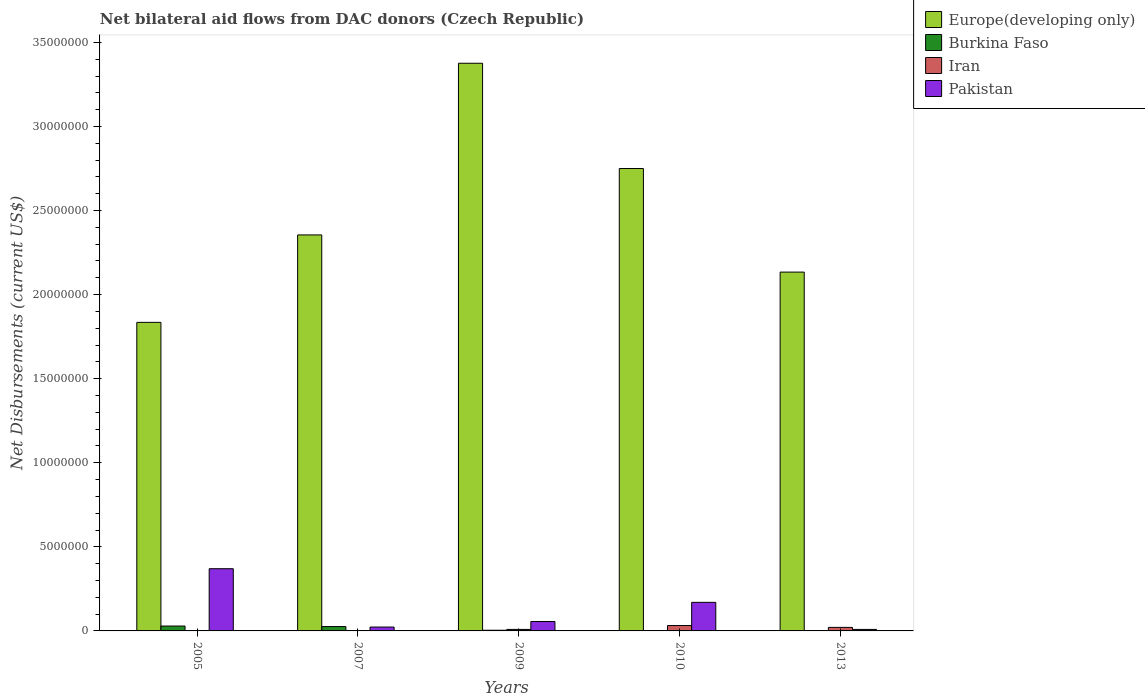How many different coloured bars are there?
Ensure brevity in your answer.  4. Are the number of bars per tick equal to the number of legend labels?
Keep it short and to the point. Yes. Are the number of bars on each tick of the X-axis equal?
Provide a succinct answer. Yes. How many bars are there on the 2nd tick from the left?
Give a very brief answer. 4. How many bars are there on the 5th tick from the right?
Your response must be concise. 4. What is the net bilateral aid flows in Europe(developing only) in 2009?
Provide a succinct answer. 3.38e+07. Across all years, what is the maximum net bilateral aid flows in Burkina Faso?
Give a very brief answer. 2.90e+05. In which year was the net bilateral aid flows in Europe(developing only) maximum?
Offer a terse response. 2009. What is the total net bilateral aid flows in Burkina Faso in the graph?
Provide a short and direct response. 6.20e+05. What is the difference between the net bilateral aid flows in Iran in 2007 and that in 2009?
Ensure brevity in your answer.  -7.00e+04. What is the difference between the net bilateral aid flows in Iran in 2007 and the net bilateral aid flows in Europe(developing only) in 2009?
Keep it short and to the point. -3.37e+07. What is the average net bilateral aid flows in Europe(developing only) per year?
Make the answer very short. 2.49e+07. In the year 2005, what is the difference between the net bilateral aid flows in Pakistan and net bilateral aid flows in Burkina Faso?
Offer a terse response. 3.41e+06. In how many years, is the net bilateral aid flows in Europe(developing only) greater than 33000000 US$?
Provide a short and direct response. 1. What is the ratio of the net bilateral aid flows in Burkina Faso in 2009 to that in 2013?
Your answer should be very brief. 4. Is the net bilateral aid flows in Burkina Faso in 2007 less than that in 2009?
Provide a succinct answer. No. Is the difference between the net bilateral aid flows in Pakistan in 2005 and 2010 greater than the difference between the net bilateral aid flows in Burkina Faso in 2005 and 2010?
Your answer should be compact. Yes. What is the difference between the highest and the lowest net bilateral aid flows in Burkina Faso?
Your answer should be compact. 2.80e+05. In how many years, is the net bilateral aid flows in Burkina Faso greater than the average net bilateral aid flows in Burkina Faso taken over all years?
Offer a very short reply. 2. Is it the case that in every year, the sum of the net bilateral aid flows in Europe(developing only) and net bilateral aid flows in Burkina Faso is greater than the sum of net bilateral aid flows in Pakistan and net bilateral aid flows in Iran?
Your answer should be compact. Yes. What does the 2nd bar from the left in 2010 represents?
Your answer should be compact. Burkina Faso. What does the 4th bar from the right in 2010 represents?
Offer a very short reply. Europe(developing only). What is the difference between two consecutive major ticks on the Y-axis?
Give a very brief answer. 5.00e+06. Does the graph contain any zero values?
Provide a short and direct response. No. Does the graph contain grids?
Your answer should be compact. No. Where does the legend appear in the graph?
Provide a short and direct response. Top right. How many legend labels are there?
Ensure brevity in your answer.  4. How are the legend labels stacked?
Make the answer very short. Vertical. What is the title of the graph?
Give a very brief answer. Net bilateral aid flows from DAC donors (Czech Republic). Does "Sao Tome and Principe" appear as one of the legend labels in the graph?
Give a very brief answer. No. What is the label or title of the X-axis?
Your answer should be compact. Years. What is the label or title of the Y-axis?
Your answer should be very brief. Net Disbursements (current US$). What is the Net Disbursements (current US$) of Europe(developing only) in 2005?
Offer a terse response. 1.84e+07. What is the Net Disbursements (current US$) in Pakistan in 2005?
Offer a terse response. 3.70e+06. What is the Net Disbursements (current US$) of Europe(developing only) in 2007?
Provide a succinct answer. 2.36e+07. What is the Net Disbursements (current US$) in Iran in 2007?
Provide a succinct answer. 2.00e+04. What is the Net Disbursements (current US$) in Pakistan in 2007?
Offer a very short reply. 2.30e+05. What is the Net Disbursements (current US$) in Europe(developing only) in 2009?
Your answer should be very brief. 3.38e+07. What is the Net Disbursements (current US$) of Iran in 2009?
Ensure brevity in your answer.  9.00e+04. What is the Net Disbursements (current US$) in Pakistan in 2009?
Offer a terse response. 5.60e+05. What is the Net Disbursements (current US$) in Europe(developing only) in 2010?
Your response must be concise. 2.75e+07. What is the Net Disbursements (current US$) of Burkina Faso in 2010?
Offer a very short reply. 2.00e+04. What is the Net Disbursements (current US$) of Pakistan in 2010?
Your response must be concise. 1.70e+06. What is the Net Disbursements (current US$) of Europe(developing only) in 2013?
Provide a short and direct response. 2.13e+07. What is the Net Disbursements (current US$) in Pakistan in 2013?
Your answer should be compact. 9.00e+04. Across all years, what is the maximum Net Disbursements (current US$) in Europe(developing only)?
Give a very brief answer. 3.38e+07. Across all years, what is the maximum Net Disbursements (current US$) of Pakistan?
Ensure brevity in your answer.  3.70e+06. Across all years, what is the minimum Net Disbursements (current US$) of Europe(developing only)?
Your answer should be very brief. 1.84e+07. Across all years, what is the minimum Net Disbursements (current US$) in Burkina Faso?
Provide a succinct answer. 10000. What is the total Net Disbursements (current US$) of Europe(developing only) in the graph?
Give a very brief answer. 1.24e+08. What is the total Net Disbursements (current US$) in Burkina Faso in the graph?
Provide a succinct answer. 6.20e+05. What is the total Net Disbursements (current US$) in Pakistan in the graph?
Ensure brevity in your answer.  6.28e+06. What is the difference between the Net Disbursements (current US$) in Europe(developing only) in 2005 and that in 2007?
Keep it short and to the point. -5.20e+06. What is the difference between the Net Disbursements (current US$) in Pakistan in 2005 and that in 2007?
Your answer should be very brief. 3.47e+06. What is the difference between the Net Disbursements (current US$) in Europe(developing only) in 2005 and that in 2009?
Your response must be concise. -1.54e+07. What is the difference between the Net Disbursements (current US$) in Burkina Faso in 2005 and that in 2009?
Offer a terse response. 2.50e+05. What is the difference between the Net Disbursements (current US$) in Iran in 2005 and that in 2009?
Your answer should be compact. -7.00e+04. What is the difference between the Net Disbursements (current US$) in Pakistan in 2005 and that in 2009?
Your answer should be very brief. 3.14e+06. What is the difference between the Net Disbursements (current US$) of Europe(developing only) in 2005 and that in 2010?
Your response must be concise. -9.15e+06. What is the difference between the Net Disbursements (current US$) of Burkina Faso in 2005 and that in 2010?
Keep it short and to the point. 2.70e+05. What is the difference between the Net Disbursements (current US$) in Europe(developing only) in 2005 and that in 2013?
Provide a succinct answer. -2.99e+06. What is the difference between the Net Disbursements (current US$) of Burkina Faso in 2005 and that in 2013?
Give a very brief answer. 2.80e+05. What is the difference between the Net Disbursements (current US$) of Iran in 2005 and that in 2013?
Offer a terse response. -1.90e+05. What is the difference between the Net Disbursements (current US$) of Pakistan in 2005 and that in 2013?
Ensure brevity in your answer.  3.61e+06. What is the difference between the Net Disbursements (current US$) in Europe(developing only) in 2007 and that in 2009?
Keep it short and to the point. -1.02e+07. What is the difference between the Net Disbursements (current US$) in Burkina Faso in 2007 and that in 2009?
Give a very brief answer. 2.20e+05. What is the difference between the Net Disbursements (current US$) in Iran in 2007 and that in 2009?
Give a very brief answer. -7.00e+04. What is the difference between the Net Disbursements (current US$) in Pakistan in 2007 and that in 2009?
Keep it short and to the point. -3.30e+05. What is the difference between the Net Disbursements (current US$) in Europe(developing only) in 2007 and that in 2010?
Your answer should be very brief. -3.95e+06. What is the difference between the Net Disbursements (current US$) in Pakistan in 2007 and that in 2010?
Provide a short and direct response. -1.47e+06. What is the difference between the Net Disbursements (current US$) of Europe(developing only) in 2007 and that in 2013?
Make the answer very short. 2.21e+06. What is the difference between the Net Disbursements (current US$) of Iran in 2007 and that in 2013?
Provide a succinct answer. -1.90e+05. What is the difference between the Net Disbursements (current US$) in Pakistan in 2007 and that in 2013?
Make the answer very short. 1.40e+05. What is the difference between the Net Disbursements (current US$) of Europe(developing only) in 2009 and that in 2010?
Make the answer very short. 6.26e+06. What is the difference between the Net Disbursements (current US$) in Burkina Faso in 2009 and that in 2010?
Your answer should be very brief. 2.00e+04. What is the difference between the Net Disbursements (current US$) of Pakistan in 2009 and that in 2010?
Offer a terse response. -1.14e+06. What is the difference between the Net Disbursements (current US$) in Europe(developing only) in 2009 and that in 2013?
Provide a short and direct response. 1.24e+07. What is the difference between the Net Disbursements (current US$) of Burkina Faso in 2009 and that in 2013?
Your response must be concise. 3.00e+04. What is the difference between the Net Disbursements (current US$) in Europe(developing only) in 2010 and that in 2013?
Give a very brief answer. 6.16e+06. What is the difference between the Net Disbursements (current US$) in Pakistan in 2010 and that in 2013?
Your answer should be compact. 1.61e+06. What is the difference between the Net Disbursements (current US$) in Europe(developing only) in 2005 and the Net Disbursements (current US$) in Burkina Faso in 2007?
Ensure brevity in your answer.  1.81e+07. What is the difference between the Net Disbursements (current US$) of Europe(developing only) in 2005 and the Net Disbursements (current US$) of Iran in 2007?
Offer a terse response. 1.83e+07. What is the difference between the Net Disbursements (current US$) in Europe(developing only) in 2005 and the Net Disbursements (current US$) in Pakistan in 2007?
Your response must be concise. 1.81e+07. What is the difference between the Net Disbursements (current US$) of Burkina Faso in 2005 and the Net Disbursements (current US$) of Pakistan in 2007?
Your response must be concise. 6.00e+04. What is the difference between the Net Disbursements (current US$) of Europe(developing only) in 2005 and the Net Disbursements (current US$) of Burkina Faso in 2009?
Provide a short and direct response. 1.83e+07. What is the difference between the Net Disbursements (current US$) of Europe(developing only) in 2005 and the Net Disbursements (current US$) of Iran in 2009?
Offer a terse response. 1.83e+07. What is the difference between the Net Disbursements (current US$) of Europe(developing only) in 2005 and the Net Disbursements (current US$) of Pakistan in 2009?
Give a very brief answer. 1.78e+07. What is the difference between the Net Disbursements (current US$) of Burkina Faso in 2005 and the Net Disbursements (current US$) of Iran in 2009?
Ensure brevity in your answer.  2.00e+05. What is the difference between the Net Disbursements (current US$) in Burkina Faso in 2005 and the Net Disbursements (current US$) in Pakistan in 2009?
Your answer should be compact. -2.70e+05. What is the difference between the Net Disbursements (current US$) in Iran in 2005 and the Net Disbursements (current US$) in Pakistan in 2009?
Provide a short and direct response. -5.40e+05. What is the difference between the Net Disbursements (current US$) in Europe(developing only) in 2005 and the Net Disbursements (current US$) in Burkina Faso in 2010?
Keep it short and to the point. 1.83e+07. What is the difference between the Net Disbursements (current US$) of Europe(developing only) in 2005 and the Net Disbursements (current US$) of Iran in 2010?
Your response must be concise. 1.80e+07. What is the difference between the Net Disbursements (current US$) in Europe(developing only) in 2005 and the Net Disbursements (current US$) in Pakistan in 2010?
Your response must be concise. 1.66e+07. What is the difference between the Net Disbursements (current US$) in Burkina Faso in 2005 and the Net Disbursements (current US$) in Iran in 2010?
Your answer should be very brief. -3.00e+04. What is the difference between the Net Disbursements (current US$) of Burkina Faso in 2005 and the Net Disbursements (current US$) of Pakistan in 2010?
Your answer should be very brief. -1.41e+06. What is the difference between the Net Disbursements (current US$) of Iran in 2005 and the Net Disbursements (current US$) of Pakistan in 2010?
Offer a very short reply. -1.68e+06. What is the difference between the Net Disbursements (current US$) in Europe(developing only) in 2005 and the Net Disbursements (current US$) in Burkina Faso in 2013?
Offer a very short reply. 1.83e+07. What is the difference between the Net Disbursements (current US$) in Europe(developing only) in 2005 and the Net Disbursements (current US$) in Iran in 2013?
Ensure brevity in your answer.  1.81e+07. What is the difference between the Net Disbursements (current US$) in Europe(developing only) in 2005 and the Net Disbursements (current US$) in Pakistan in 2013?
Ensure brevity in your answer.  1.83e+07. What is the difference between the Net Disbursements (current US$) of Burkina Faso in 2005 and the Net Disbursements (current US$) of Pakistan in 2013?
Your answer should be compact. 2.00e+05. What is the difference between the Net Disbursements (current US$) of Iran in 2005 and the Net Disbursements (current US$) of Pakistan in 2013?
Your response must be concise. -7.00e+04. What is the difference between the Net Disbursements (current US$) in Europe(developing only) in 2007 and the Net Disbursements (current US$) in Burkina Faso in 2009?
Provide a short and direct response. 2.35e+07. What is the difference between the Net Disbursements (current US$) of Europe(developing only) in 2007 and the Net Disbursements (current US$) of Iran in 2009?
Your answer should be compact. 2.35e+07. What is the difference between the Net Disbursements (current US$) of Europe(developing only) in 2007 and the Net Disbursements (current US$) of Pakistan in 2009?
Keep it short and to the point. 2.30e+07. What is the difference between the Net Disbursements (current US$) in Iran in 2007 and the Net Disbursements (current US$) in Pakistan in 2009?
Provide a short and direct response. -5.40e+05. What is the difference between the Net Disbursements (current US$) of Europe(developing only) in 2007 and the Net Disbursements (current US$) of Burkina Faso in 2010?
Your response must be concise. 2.35e+07. What is the difference between the Net Disbursements (current US$) of Europe(developing only) in 2007 and the Net Disbursements (current US$) of Iran in 2010?
Offer a very short reply. 2.32e+07. What is the difference between the Net Disbursements (current US$) in Europe(developing only) in 2007 and the Net Disbursements (current US$) in Pakistan in 2010?
Ensure brevity in your answer.  2.18e+07. What is the difference between the Net Disbursements (current US$) of Burkina Faso in 2007 and the Net Disbursements (current US$) of Iran in 2010?
Provide a short and direct response. -6.00e+04. What is the difference between the Net Disbursements (current US$) in Burkina Faso in 2007 and the Net Disbursements (current US$) in Pakistan in 2010?
Provide a short and direct response. -1.44e+06. What is the difference between the Net Disbursements (current US$) in Iran in 2007 and the Net Disbursements (current US$) in Pakistan in 2010?
Your response must be concise. -1.68e+06. What is the difference between the Net Disbursements (current US$) of Europe(developing only) in 2007 and the Net Disbursements (current US$) of Burkina Faso in 2013?
Make the answer very short. 2.35e+07. What is the difference between the Net Disbursements (current US$) of Europe(developing only) in 2007 and the Net Disbursements (current US$) of Iran in 2013?
Provide a short and direct response. 2.33e+07. What is the difference between the Net Disbursements (current US$) of Europe(developing only) in 2007 and the Net Disbursements (current US$) of Pakistan in 2013?
Offer a very short reply. 2.35e+07. What is the difference between the Net Disbursements (current US$) of Burkina Faso in 2007 and the Net Disbursements (current US$) of Iran in 2013?
Your answer should be compact. 5.00e+04. What is the difference between the Net Disbursements (current US$) in Burkina Faso in 2007 and the Net Disbursements (current US$) in Pakistan in 2013?
Your answer should be compact. 1.70e+05. What is the difference between the Net Disbursements (current US$) in Europe(developing only) in 2009 and the Net Disbursements (current US$) in Burkina Faso in 2010?
Provide a succinct answer. 3.37e+07. What is the difference between the Net Disbursements (current US$) in Europe(developing only) in 2009 and the Net Disbursements (current US$) in Iran in 2010?
Give a very brief answer. 3.34e+07. What is the difference between the Net Disbursements (current US$) of Europe(developing only) in 2009 and the Net Disbursements (current US$) of Pakistan in 2010?
Your response must be concise. 3.21e+07. What is the difference between the Net Disbursements (current US$) of Burkina Faso in 2009 and the Net Disbursements (current US$) of Iran in 2010?
Your answer should be compact. -2.80e+05. What is the difference between the Net Disbursements (current US$) of Burkina Faso in 2009 and the Net Disbursements (current US$) of Pakistan in 2010?
Give a very brief answer. -1.66e+06. What is the difference between the Net Disbursements (current US$) in Iran in 2009 and the Net Disbursements (current US$) in Pakistan in 2010?
Make the answer very short. -1.61e+06. What is the difference between the Net Disbursements (current US$) in Europe(developing only) in 2009 and the Net Disbursements (current US$) in Burkina Faso in 2013?
Provide a succinct answer. 3.38e+07. What is the difference between the Net Disbursements (current US$) of Europe(developing only) in 2009 and the Net Disbursements (current US$) of Iran in 2013?
Make the answer very short. 3.36e+07. What is the difference between the Net Disbursements (current US$) of Europe(developing only) in 2009 and the Net Disbursements (current US$) of Pakistan in 2013?
Give a very brief answer. 3.37e+07. What is the difference between the Net Disbursements (current US$) of Burkina Faso in 2009 and the Net Disbursements (current US$) of Iran in 2013?
Provide a succinct answer. -1.70e+05. What is the difference between the Net Disbursements (current US$) in Europe(developing only) in 2010 and the Net Disbursements (current US$) in Burkina Faso in 2013?
Offer a terse response. 2.75e+07. What is the difference between the Net Disbursements (current US$) in Europe(developing only) in 2010 and the Net Disbursements (current US$) in Iran in 2013?
Provide a succinct answer. 2.73e+07. What is the difference between the Net Disbursements (current US$) of Europe(developing only) in 2010 and the Net Disbursements (current US$) of Pakistan in 2013?
Offer a very short reply. 2.74e+07. What is the difference between the Net Disbursements (current US$) of Burkina Faso in 2010 and the Net Disbursements (current US$) of Iran in 2013?
Make the answer very short. -1.90e+05. What is the difference between the Net Disbursements (current US$) in Iran in 2010 and the Net Disbursements (current US$) in Pakistan in 2013?
Offer a terse response. 2.30e+05. What is the average Net Disbursements (current US$) of Europe(developing only) per year?
Your answer should be compact. 2.49e+07. What is the average Net Disbursements (current US$) in Burkina Faso per year?
Give a very brief answer. 1.24e+05. What is the average Net Disbursements (current US$) of Iran per year?
Provide a succinct answer. 1.32e+05. What is the average Net Disbursements (current US$) of Pakistan per year?
Offer a very short reply. 1.26e+06. In the year 2005, what is the difference between the Net Disbursements (current US$) in Europe(developing only) and Net Disbursements (current US$) in Burkina Faso?
Your answer should be compact. 1.81e+07. In the year 2005, what is the difference between the Net Disbursements (current US$) in Europe(developing only) and Net Disbursements (current US$) in Iran?
Provide a short and direct response. 1.83e+07. In the year 2005, what is the difference between the Net Disbursements (current US$) in Europe(developing only) and Net Disbursements (current US$) in Pakistan?
Ensure brevity in your answer.  1.46e+07. In the year 2005, what is the difference between the Net Disbursements (current US$) in Burkina Faso and Net Disbursements (current US$) in Pakistan?
Your response must be concise. -3.41e+06. In the year 2005, what is the difference between the Net Disbursements (current US$) of Iran and Net Disbursements (current US$) of Pakistan?
Your answer should be very brief. -3.68e+06. In the year 2007, what is the difference between the Net Disbursements (current US$) in Europe(developing only) and Net Disbursements (current US$) in Burkina Faso?
Provide a succinct answer. 2.33e+07. In the year 2007, what is the difference between the Net Disbursements (current US$) in Europe(developing only) and Net Disbursements (current US$) in Iran?
Your answer should be very brief. 2.35e+07. In the year 2007, what is the difference between the Net Disbursements (current US$) of Europe(developing only) and Net Disbursements (current US$) of Pakistan?
Provide a short and direct response. 2.33e+07. In the year 2007, what is the difference between the Net Disbursements (current US$) in Burkina Faso and Net Disbursements (current US$) in Iran?
Provide a short and direct response. 2.40e+05. In the year 2009, what is the difference between the Net Disbursements (current US$) in Europe(developing only) and Net Disbursements (current US$) in Burkina Faso?
Offer a terse response. 3.37e+07. In the year 2009, what is the difference between the Net Disbursements (current US$) in Europe(developing only) and Net Disbursements (current US$) in Iran?
Give a very brief answer. 3.37e+07. In the year 2009, what is the difference between the Net Disbursements (current US$) in Europe(developing only) and Net Disbursements (current US$) in Pakistan?
Offer a very short reply. 3.32e+07. In the year 2009, what is the difference between the Net Disbursements (current US$) in Burkina Faso and Net Disbursements (current US$) in Iran?
Keep it short and to the point. -5.00e+04. In the year 2009, what is the difference between the Net Disbursements (current US$) of Burkina Faso and Net Disbursements (current US$) of Pakistan?
Ensure brevity in your answer.  -5.20e+05. In the year 2009, what is the difference between the Net Disbursements (current US$) of Iran and Net Disbursements (current US$) of Pakistan?
Your response must be concise. -4.70e+05. In the year 2010, what is the difference between the Net Disbursements (current US$) in Europe(developing only) and Net Disbursements (current US$) in Burkina Faso?
Provide a short and direct response. 2.75e+07. In the year 2010, what is the difference between the Net Disbursements (current US$) of Europe(developing only) and Net Disbursements (current US$) of Iran?
Your response must be concise. 2.72e+07. In the year 2010, what is the difference between the Net Disbursements (current US$) in Europe(developing only) and Net Disbursements (current US$) in Pakistan?
Offer a very short reply. 2.58e+07. In the year 2010, what is the difference between the Net Disbursements (current US$) in Burkina Faso and Net Disbursements (current US$) in Pakistan?
Provide a succinct answer. -1.68e+06. In the year 2010, what is the difference between the Net Disbursements (current US$) in Iran and Net Disbursements (current US$) in Pakistan?
Offer a terse response. -1.38e+06. In the year 2013, what is the difference between the Net Disbursements (current US$) of Europe(developing only) and Net Disbursements (current US$) of Burkina Faso?
Provide a succinct answer. 2.13e+07. In the year 2013, what is the difference between the Net Disbursements (current US$) in Europe(developing only) and Net Disbursements (current US$) in Iran?
Offer a terse response. 2.11e+07. In the year 2013, what is the difference between the Net Disbursements (current US$) in Europe(developing only) and Net Disbursements (current US$) in Pakistan?
Offer a terse response. 2.12e+07. In the year 2013, what is the difference between the Net Disbursements (current US$) of Burkina Faso and Net Disbursements (current US$) of Iran?
Offer a terse response. -2.00e+05. In the year 2013, what is the difference between the Net Disbursements (current US$) in Burkina Faso and Net Disbursements (current US$) in Pakistan?
Your answer should be compact. -8.00e+04. What is the ratio of the Net Disbursements (current US$) in Europe(developing only) in 2005 to that in 2007?
Make the answer very short. 0.78. What is the ratio of the Net Disbursements (current US$) of Burkina Faso in 2005 to that in 2007?
Provide a short and direct response. 1.12. What is the ratio of the Net Disbursements (current US$) in Pakistan in 2005 to that in 2007?
Provide a succinct answer. 16.09. What is the ratio of the Net Disbursements (current US$) of Europe(developing only) in 2005 to that in 2009?
Provide a succinct answer. 0.54. What is the ratio of the Net Disbursements (current US$) of Burkina Faso in 2005 to that in 2009?
Ensure brevity in your answer.  7.25. What is the ratio of the Net Disbursements (current US$) in Iran in 2005 to that in 2009?
Keep it short and to the point. 0.22. What is the ratio of the Net Disbursements (current US$) of Pakistan in 2005 to that in 2009?
Offer a terse response. 6.61. What is the ratio of the Net Disbursements (current US$) of Europe(developing only) in 2005 to that in 2010?
Your answer should be compact. 0.67. What is the ratio of the Net Disbursements (current US$) of Iran in 2005 to that in 2010?
Your answer should be very brief. 0.06. What is the ratio of the Net Disbursements (current US$) of Pakistan in 2005 to that in 2010?
Offer a terse response. 2.18. What is the ratio of the Net Disbursements (current US$) of Europe(developing only) in 2005 to that in 2013?
Provide a short and direct response. 0.86. What is the ratio of the Net Disbursements (current US$) of Burkina Faso in 2005 to that in 2013?
Make the answer very short. 29. What is the ratio of the Net Disbursements (current US$) of Iran in 2005 to that in 2013?
Your answer should be very brief. 0.1. What is the ratio of the Net Disbursements (current US$) of Pakistan in 2005 to that in 2013?
Ensure brevity in your answer.  41.11. What is the ratio of the Net Disbursements (current US$) in Europe(developing only) in 2007 to that in 2009?
Provide a short and direct response. 0.7. What is the ratio of the Net Disbursements (current US$) in Iran in 2007 to that in 2009?
Your response must be concise. 0.22. What is the ratio of the Net Disbursements (current US$) in Pakistan in 2007 to that in 2009?
Give a very brief answer. 0.41. What is the ratio of the Net Disbursements (current US$) of Europe(developing only) in 2007 to that in 2010?
Your response must be concise. 0.86. What is the ratio of the Net Disbursements (current US$) in Iran in 2007 to that in 2010?
Offer a terse response. 0.06. What is the ratio of the Net Disbursements (current US$) in Pakistan in 2007 to that in 2010?
Provide a succinct answer. 0.14. What is the ratio of the Net Disbursements (current US$) of Europe(developing only) in 2007 to that in 2013?
Provide a succinct answer. 1.1. What is the ratio of the Net Disbursements (current US$) of Iran in 2007 to that in 2013?
Your answer should be very brief. 0.1. What is the ratio of the Net Disbursements (current US$) of Pakistan in 2007 to that in 2013?
Your answer should be compact. 2.56. What is the ratio of the Net Disbursements (current US$) in Europe(developing only) in 2009 to that in 2010?
Keep it short and to the point. 1.23. What is the ratio of the Net Disbursements (current US$) in Burkina Faso in 2009 to that in 2010?
Make the answer very short. 2. What is the ratio of the Net Disbursements (current US$) of Iran in 2009 to that in 2010?
Give a very brief answer. 0.28. What is the ratio of the Net Disbursements (current US$) in Pakistan in 2009 to that in 2010?
Offer a terse response. 0.33. What is the ratio of the Net Disbursements (current US$) of Europe(developing only) in 2009 to that in 2013?
Make the answer very short. 1.58. What is the ratio of the Net Disbursements (current US$) of Burkina Faso in 2009 to that in 2013?
Give a very brief answer. 4. What is the ratio of the Net Disbursements (current US$) in Iran in 2009 to that in 2013?
Your answer should be very brief. 0.43. What is the ratio of the Net Disbursements (current US$) of Pakistan in 2009 to that in 2013?
Ensure brevity in your answer.  6.22. What is the ratio of the Net Disbursements (current US$) of Europe(developing only) in 2010 to that in 2013?
Your answer should be compact. 1.29. What is the ratio of the Net Disbursements (current US$) in Burkina Faso in 2010 to that in 2013?
Your answer should be compact. 2. What is the ratio of the Net Disbursements (current US$) of Iran in 2010 to that in 2013?
Make the answer very short. 1.52. What is the ratio of the Net Disbursements (current US$) of Pakistan in 2010 to that in 2013?
Your answer should be compact. 18.89. What is the difference between the highest and the second highest Net Disbursements (current US$) in Europe(developing only)?
Offer a very short reply. 6.26e+06. What is the difference between the highest and the second highest Net Disbursements (current US$) of Burkina Faso?
Provide a succinct answer. 3.00e+04. What is the difference between the highest and the second highest Net Disbursements (current US$) of Pakistan?
Keep it short and to the point. 2.00e+06. What is the difference between the highest and the lowest Net Disbursements (current US$) in Europe(developing only)?
Your answer should be compact. 1.54e+07. What is the difference between the highest and the lowest Net Disbursements (current US$) in Burkina Faso?
Make the answer very short. 2.80e+05. What is the difference between the highest and the lowest Net Disbursements (current US$) in Iran?
Make the answer very short. 3.00e+05. What is the difference between the highest and the lowest Net Disbursements (current US$) in Pakistan?
Offer a terse response. 3.61e+06. 